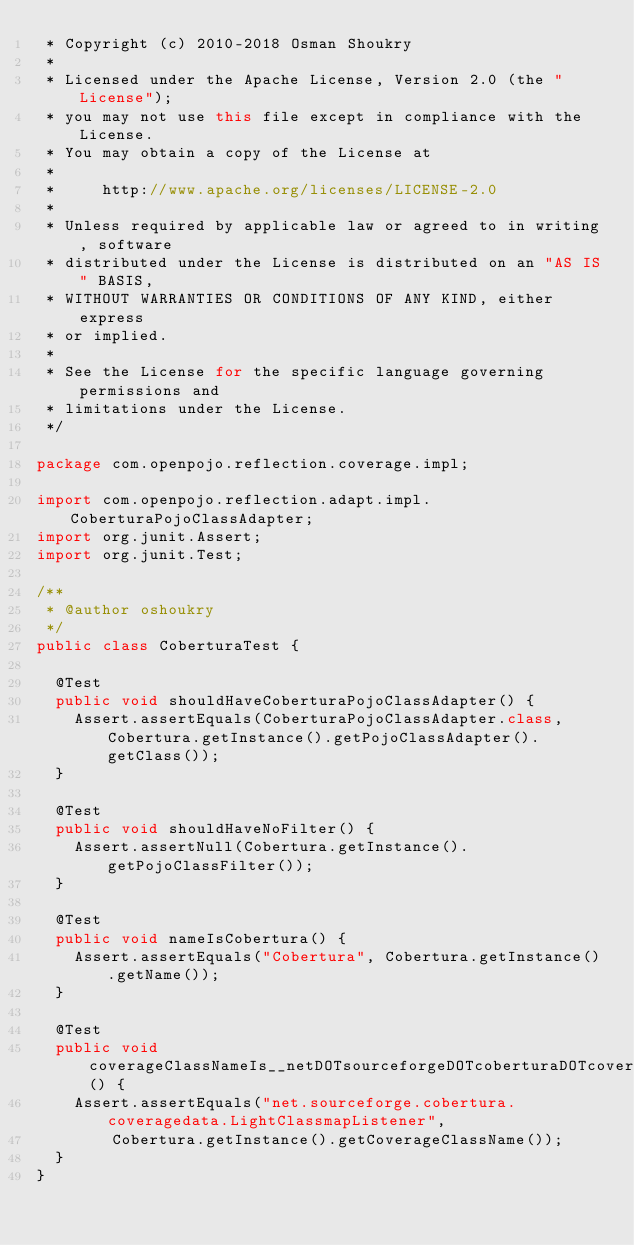Convert code to text. <code><loc_0><loc_0><loc_500><loc_500><_Java_> * Copyright (c) 2010-2018 Osman Shoukry
 *
 * Licensed under the Apache License, Version 2.0 (the "License");
 * you may not use this file except in compliance with the License.
 * You may obtain a copy of the License at
 *
 *     http://www.apache.org/licenses/LICENSE-2.0
 *
 * Unless required by applicable law or agreed to in writing, software
 * distributed under the License is distributed on an "AS IS" BASIS,
 * WITHOUT WARRANTIES OR CONDITIONS OF ANY KIND, either express
 * or implied.
 *
 * See the License for the specific language governing permissions and
 * limitations under the License.
 */

package com.openpojo.reflection.coverage.impl;

import com.openpojo.reflection.adapt.impl.CoberturaPojoClassAdapter;
import org.junit.Assert;
import org.junit.Test;

/**
 * @author oshoukry
 */
public class CoberturaTest {

  @Test
  public void shouldHaveCoberturaPojoClassAdapter() {
    Assert.assertEquals(CoberturaPojoClassAdapter.class, Cobertura.getInstance().getPojoClassAdapter().getClass());
  }

  @Test
  public void shouldHaveNoFilter() {
    Assert.assertNull(Cobertura.getInstance().getPojoClassFilter());
  }

  @Test
  public void nameIsCobertura() {
    Assert.assertEquals("Cobertura", Cobertura.getInstance().getName());
  }

  @Test
  public void coverageClassNameIs__netDOTsourceforgeDOTcoberturaDOTcoveragedataDOTLightClassmapListener() {
    Assert.assertEquals("net.sourceforge.cobertura.coveragedata.LightClassmapListener",
        Cobertura.getInstance().getCoverageClassName());
  }
}
</code> 